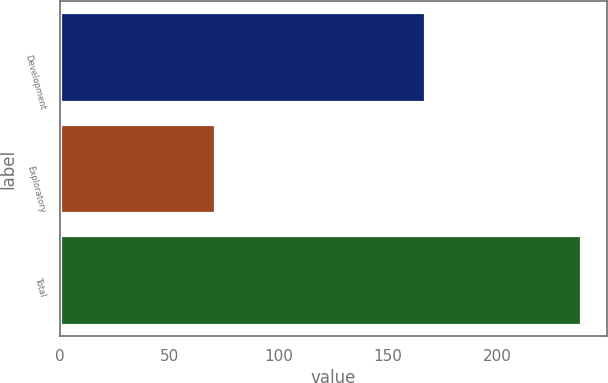Convert chart to OTSL. <chart><loc_0><loc_0><loc_500><loc_500><bar_chart><fcel>Development<fcel>Exploratory<fcel>Total<nl><fcel>167<fcel>71<fcel>238<nl></chart> 